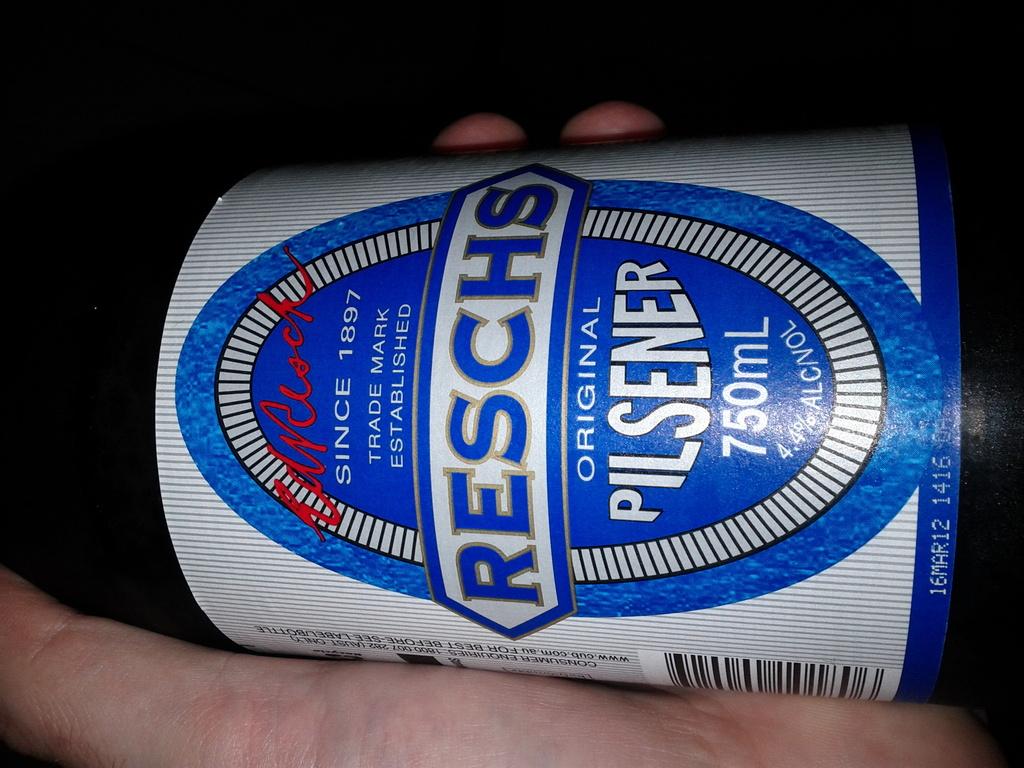How much alcohol is in the bottle?
Make the answer very short. 4.4%. 